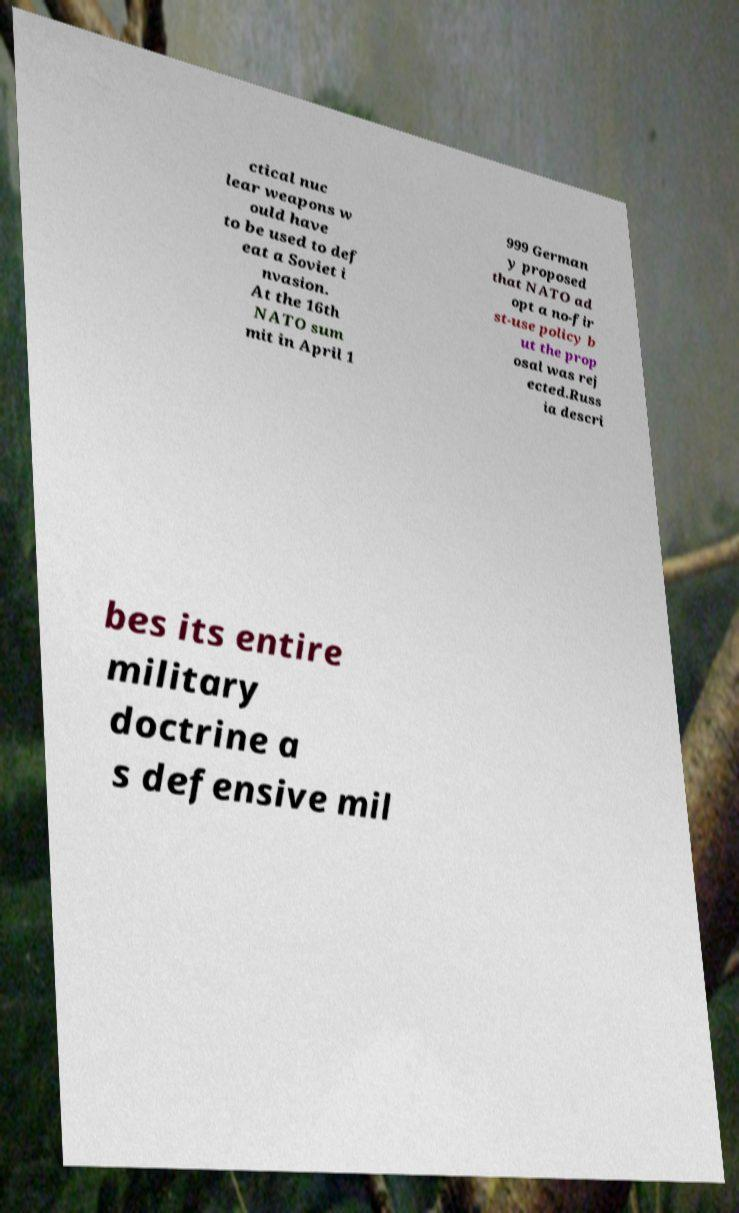Please read and relay the text visible in this image. What does it say? ctical nuc lear weapons w ould have to be used to def eat a Soviet i nvasion. At the 16th NATO sum mit in April 1 999 German y proposed that NATO ad opt a no-fir st-use policy b ut the prop osal was rej ected.Russ ia descri bes its entire military doctrine a s defensive mil 